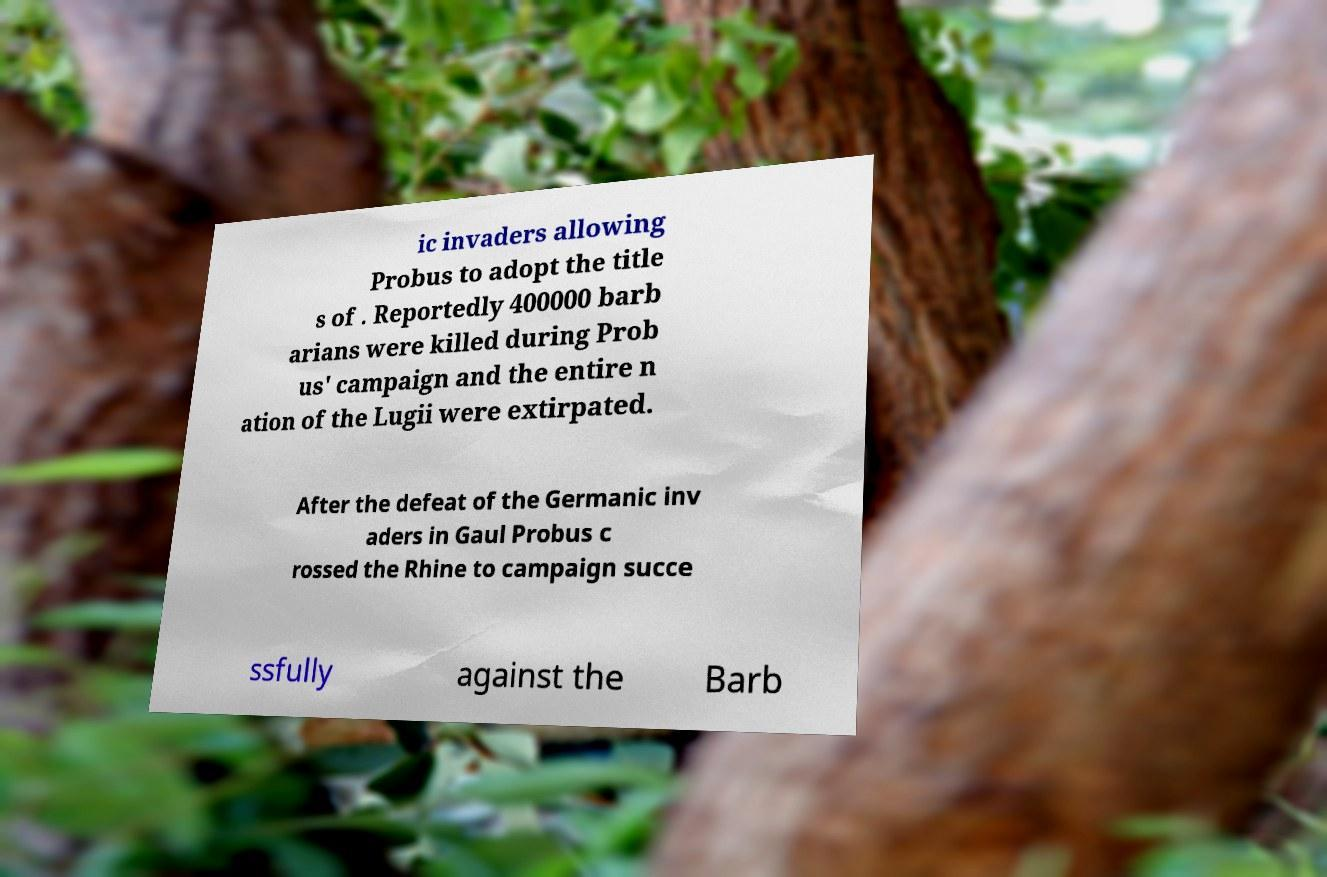There's text embedded in this image that I need extracted. Can you transcribe it verbatim? ic invaders allowing Probus to adopt the title s of . Reportedly 400000 barb arians were killed during Prob us' campaign and the entire n ation of the Lugii were extirpated. After the defeat of the Germanic inv aders in Gaul Probus c rossed the Rhine to campaign succe ssfully against the Barb 